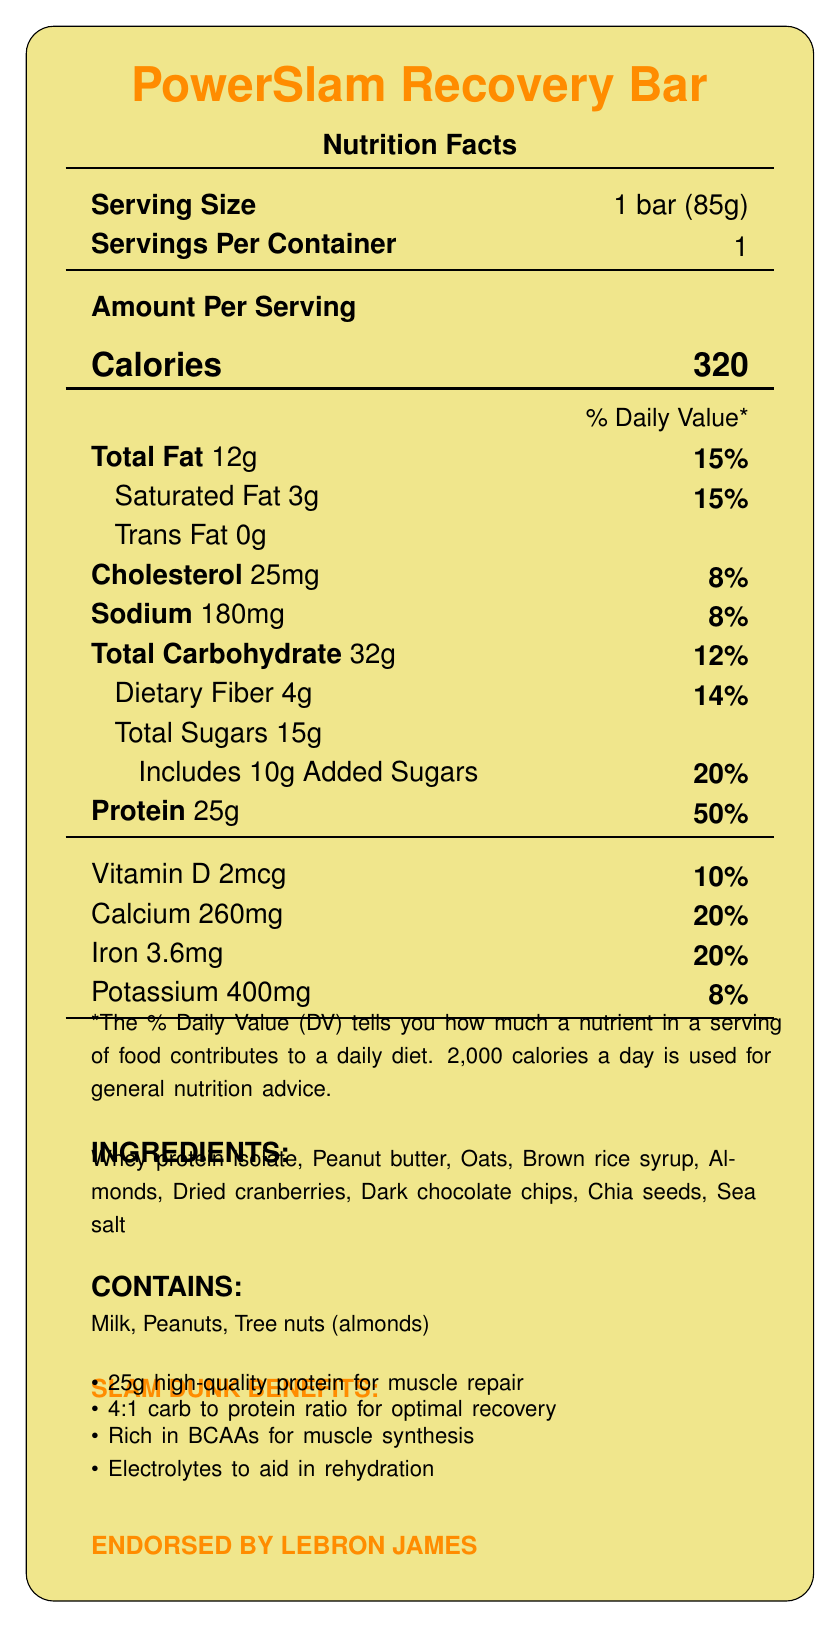What is the serving size of the PowerSlam Recovery Bar? The serving size is listed as "1 bar (85g)" under the "Serving Size" section.
Answer: 1 bar (85g) How many calories are there per serving of the PowerSlam Recovery Bar? The number of calories per serving is listed as 320 in the "Amount Per Serving" section.
Answer: 320 What percentage of the daily value does the protein content of the PowerSlam Recovery Bar provide? The protein content provides 50% of the daily value as stated next to the protein amount (25g).
Answer: 50% How much total fat does one PowerSlam Recovery Bar contain, in grams? The "Total Fat" section lists the amount as 12g.
Answer: 12g What are the main ingredients of the PowerSlam Recovery Bar? The ingredients list includes these items under the "INGREDIENTS" section.
Answer: Whey protein isolate, Peanut butter, Oats, Brown rice syrup, Almonds, Dried cranberries, Dark chocolate chips, Chia seeds, Sea salt What is the cholesterol content in one PowerSlam Recovery Bar? A. 15mg B. 20mg C. 25mg D. 30mg The "Cholesterol" section lists the amount as 25mg.
Answer: C Which athlete endorses the PowerSlam Recovery Bar? A. LeBron James B. Kevin Durant C. Stephen Curry D. Michael Jordan The "ENDORSED BY LEBRON JAMES" section clearly states the endorsement by LeBron James.
Answer: A Is the PowerSlam Recovery Bar suitable for individuals with peanut allergies? The "CONTAINS" section lists peanuts as an allergen.
Answer: No Does the PowerSlam Recovery Bar contain any trans fat? The "Trans Fat" section lists the amount as 0g.
Answer: No Summarize the key nutritional benefits of the PowerSlam Recovery Bar. The summary covers the main nutritional and performance-related highlights mentioned in the document, including the protein content, the carbohydrate to protein ratio, BCAAs, electrolytes, and the athlete endorsement.
Answer: The PowerSlam Recovery Bar is designed for optimal post-game recovery, providing 25g of high-quality protein for muscle repair, a 4:1 carbohydrate to protein ratio for optimal recovery, rich in BCAAs for muscle synthesis, and includes electrolytes to aid in rehydration. It is endorsed by LeBron James. How much dietary fiber is in each PowerSlam Recovery Bar? The amount of dietary fiber is listed as 4g in the "Dietary Fiber" section.
Answer: 4g What percentage of the daily value of calcium does each PowerSlam Recovery Bar provide? The calcium content provides 20% of the daily value as listed next to the amount (260mg).
Answer: 20% How much added sugars are there in one PowerSlam Recovery Bar? The "Includes 10g Added Sugars" section indicates the amount of added sugars.
Answer: 10g Which nutrient is present in the highest daily value percentage in the PowerSlam Recovery Bar? A. Vitamin D B. Protein C. Potassium D. Total Fat Protein has the highest daily value percentage at 50%.
Answer: B What is the exact amount of potassium in the PowerSlam Recovery Bar? The "Potassium" section lists the amount as 400mg.
Answer: 400mg Is the PowerSlam Recovery Bar intended solely for pre-game consumption? The product is designed specifically for post-game recovery, as mentioned in the "Designed for optimal post-game recovery" marketing claim.
Answer: No Who manufactures the PowerSlam Recovery Bar? The document does not provide information about the manufacturer.
Answer: Cannot be determined 